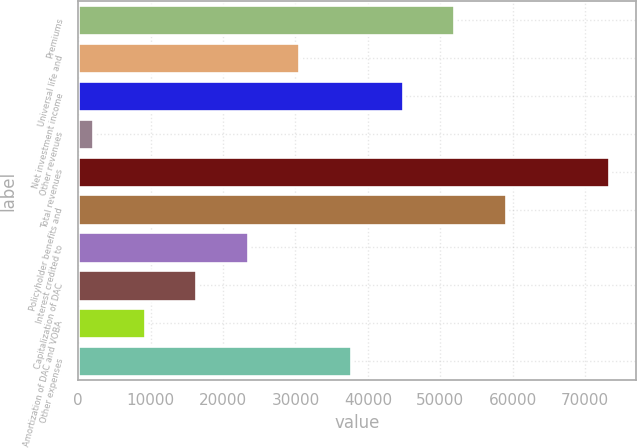Convert chart. <chart><loc_0><loc_0><loc_500><loc_500><bar_chart><fcel>Premiums<fcel>Universal life and<fcel>Net investment income<fcel>Other revenues<fcel>Total revenues<fcel>Policyholder benefits and<fcel>Interest credited to<fcel>Capitalization of DAC<fcel>Amortization of DAC and VOBA<fcel>Other expenses<nl><fcel>51930.2<fcel>30544.4<fcel>44801.6<fcel>2030<fcel>73316<fcel>59058.8<fcel>23415.8<fcel>16287.2<fcel>9158.6<fcel>37673<nl></chart> 